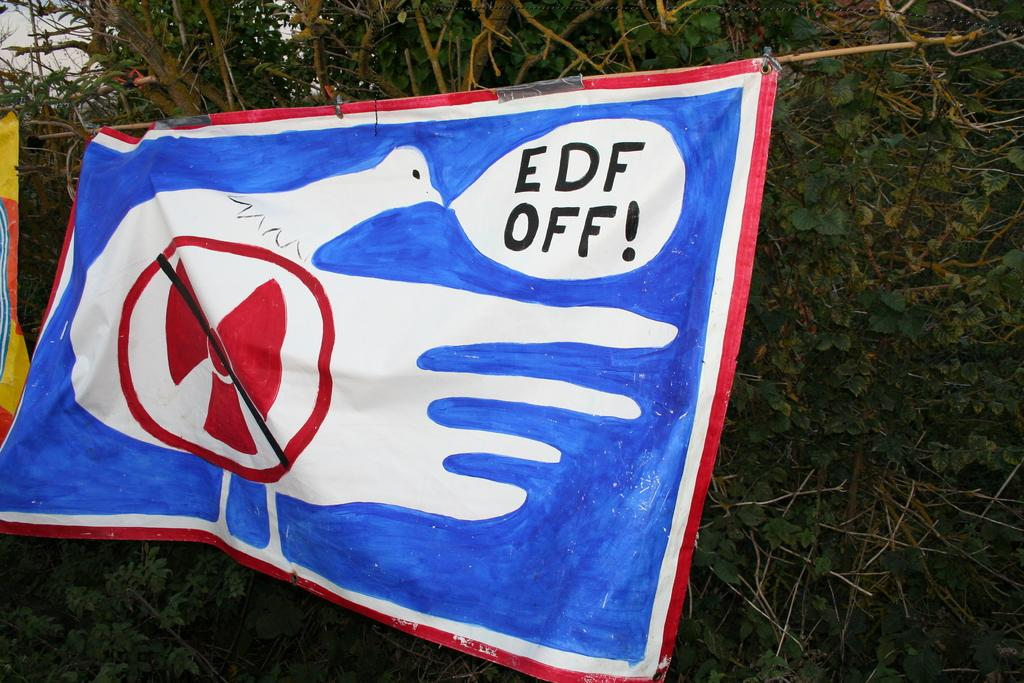What can be seen flying in the image? There are flags in the image. What type of natural elements are present in the image? There are trees in the image. Can you tell me how many horses are grazing near the river in the image? There are no horses or rivers present in the image; it only features flags and trees. 